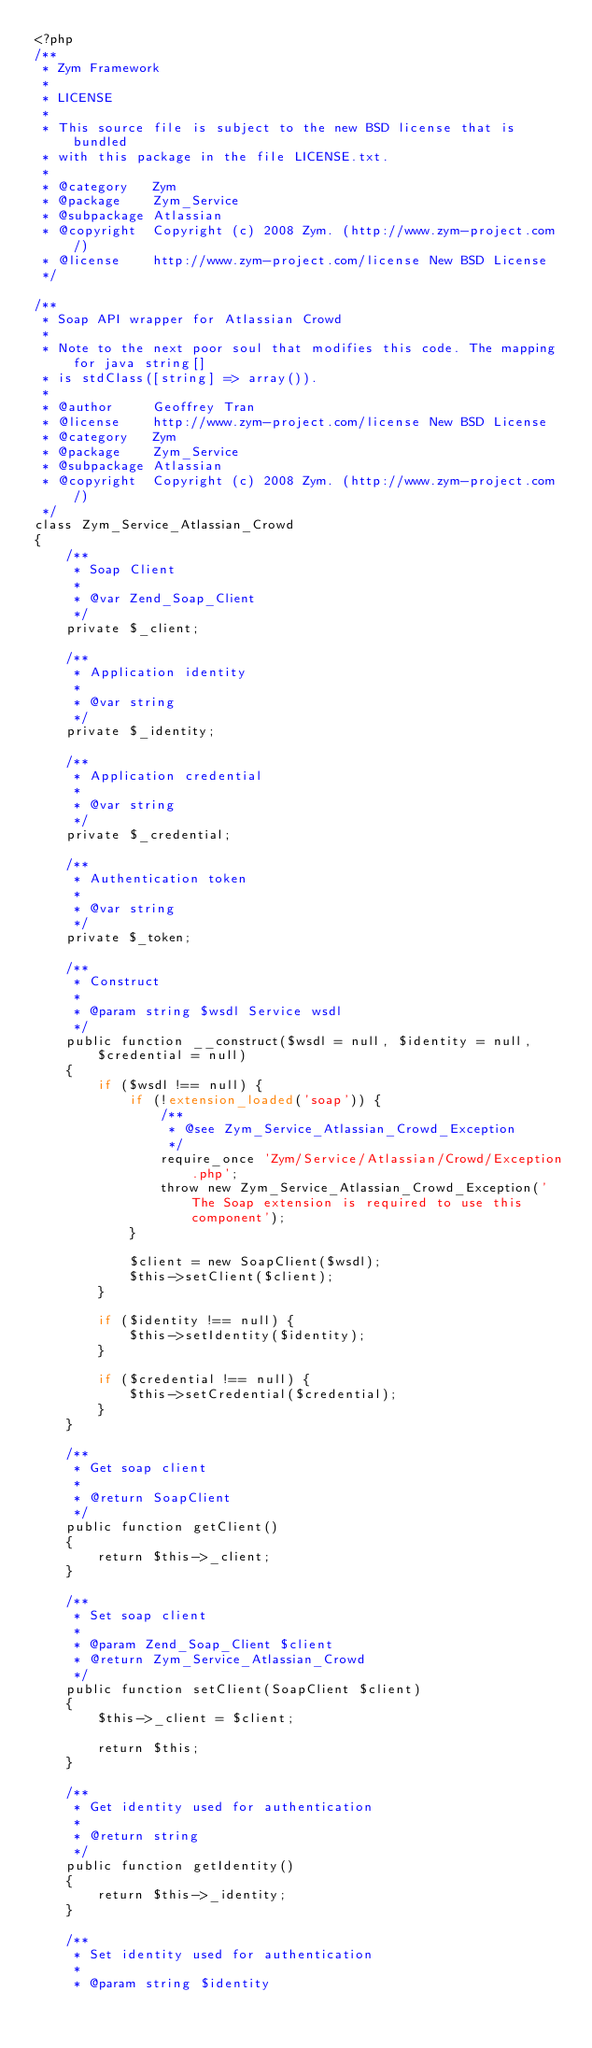Convert code to text. <code><loc_0><loc_0><loc_500><loc_500><_PHP_><?php
/**
 * Zym Framework
 *
 * LICENSE
 *
 * This source file is subject to the new BSD license that is bundled
 * with this package in the file LICENSE.txt.
 *
 * @category   Zym
 * @package    Zym_Service
 * @subpackage Atlassian
 * @copyright  Copyright (c) 2008 Zym. (http://www.zym-project.com/)
 * @license    http://www.zym-project.com/license New BSD License
 */

/**
 * Soap API wrapper for Atlassian Crowd
 *
 * Note to the next poor soul that modifies this code. The mapping for java string[]
 * is stdClass([string] => array()).
 *
 * @author     Geoffrey Tran
 * @license    http://www.zym-project.com/license New BSD License
 * @category   Zym
 * @package    Zym_Service
 * @subpackage Atlassian
 * @copyright  Copyright (c) 2008 Zym. (http://www.zym-project.com/)
 */
class Zym_Service_Atlassian_Crowd
{
    /**
     * Soap Client
     *
     * @var Zend_Soap_Client
     */
    private $_client;

    /**
     * Application identity
     *
     * @var string
     */
    private $_identity;

    /**
     * Application credential
     *
     * @var string
     */
    private $_credential;

    /**
     * Authentication token
     *
     * @var string
     */
    private $_token;

    /**
     * Construct
     *
     * @param string $wsdl Service wsdl
     */
    public function __construct($wsdl = null, $identity = null, $credential = null)
    {
        if ($wsdl !== null) {
            if (!extension_loaded('soap')) {
                /**
                 * @see Zym_Service_Atlassian_Crowd_Exception
                 */
                require_once 'Zym/Service/Atlassian/Crowd/Exception.php';
                throw new Zym_Service_Atlassian_Crowd_Exception('The Soap extension is required to use this component');
            }

            $client = new SoapClient($wsdl);
            $this->setClient($client);
        }

        if ($identity !== null) {
            $this->setIdentity($identity);
        }

        if ($credential !== null) {
            $this->setCredential($credential);
        }
    }

    /**
     * Get soap client
     *
     * @return SoapClient
     */
    public function getClient()
    {
        return $this->_client;
    }

    /**
     * Set soap client
     *
     * @param Zend_Soap_Client $client
     * @return Zym_Service_Atlassian_Crowd
     */
    public function setClient(SoapClient $client)
    {
        $this->_client = $client;

        return $this;
    }

    /**
     * Get identity used for authentication
     *
     * @return string
     */
    public function getIdentity()
    {
        return $this->_identity;
    }

    /**
     * Set identity used for authentication
     *
     * @param string $identity</code> 